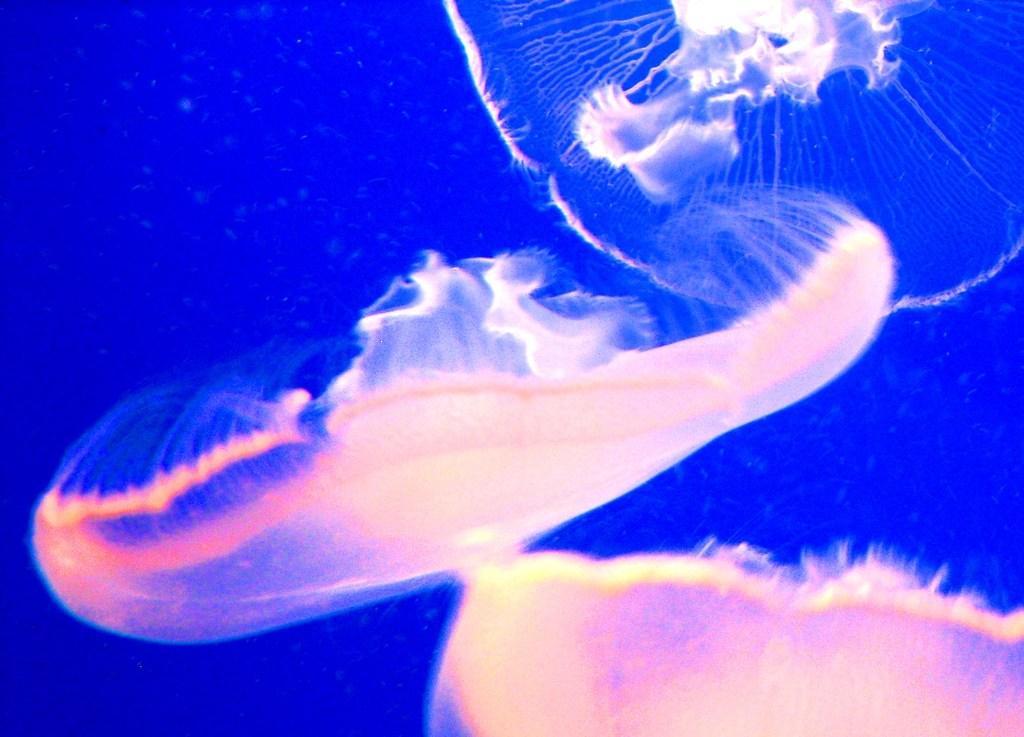Please provide a concise description of this image. In this picture there are two white color jellyfish in the sea water. Behind there is a blue background. 